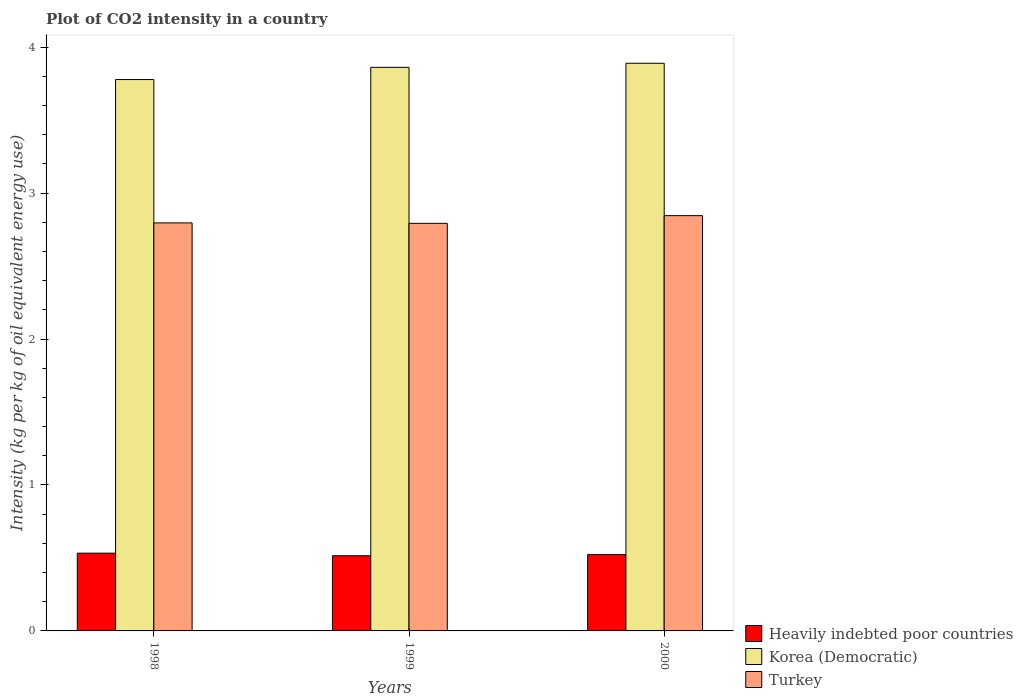How many groups of bars are there?
Offer a very short reply. 3. Are the number of bars per tick equal to the number of legend labels?
Provide a succinct answer. Yes. Are the number of bars on each tick of the X-axis equal?
Provide a succinct answer. Yes. In how many cases, is the number of bars for a given year not equal to the number of legend labels?
Offer a terse response. 0. What is the CO2 intensity in in Korea (Democratic) in 2000?
Your answer should be compact. 3.89. Across all years, what is the maximum CO2 intensity in in Korea (Democratic)?
Make the answer very short. 3.89. Across all years, what is the minimum CO2 intensity in in Korea (Democratic)?
Offer a very short reply. 3.78. In which year was the CO2 intensity in in Turkey maximum?
Your response must be concise. 2000. In which year was the CO2 intensity in in Korea (Democratic) minimum?
Your answer should be very brief. 1998. What is the total CO2 intensity in in Heavily indebted poor countries in the graph?
Provide a succinct answer. 1.57. What is the difference between the CO2 intensity in in Korea (Democratic) in 1999 and that in 2000?
Your answer should be compact. -0.03. What is the difference between the CO2 intensity in in Turkey in 1998 and the CO2 intensity in in Heavily indebted poor countries in 1999?
Ensure brevity in your answer.  2.28. What is the average CO2 intensity in in Korea (Democratic) per year?
Ensure brevity in your answer.  3.84. In the year 1998, what is the difference between the CO2 intensity in in Heavily indebted poor countries and CO2 intensity in in Turkey?
Your answer should be very brief. -2.26. What is the ratio of the CO2 intensity in in Turkey in 1998 to that in 1999?
Offer a terse response. 1. What is the difference between the highest and the second highest CO2 intensity in in Heavily indebted poor countries?
Provide a succinct answer. 0.01. What is the difference between the highest and the lowest CO2 intensity in in Korea (Democratic)?
Your answer should be very brief. 0.11. In how many years, is the CO2 intensity in in Turkey greater than the average CO2 intensity in in Turkey taken over all years?
Ensure brevity in your answer.  1. What does the 2nd bar from the left in 1998 represents?
Your answer should be very brief. Korea (Democratic). What does the 3rd bar from the right in 2000 represents?
Give a very brief answer. Heavily indebted poor countries. How many bars are there?
Give a very brief answer. 9. Are all the bars in the graph horizontal?
Keep it short and to the point. No. How many years are there in the graph?
Give a very brief answer. 3. Are the values on the major ticks of Y-axis written in scientific E-notation?
Give a very brief answer. No. Does the graph contain any zero values?
Make the answer very short. No. Does the graph contain grids?
Offer a very short reply. No. Where does the legend appear in the graph?
Make the answer very short. Bottom right. How many legend labels are there?
Give a very brief answer. 3. How are the legend labels stacked?
Your answer should be very brief. Vertical. What is the title of the graph?
Your answer should be very brief. Plot of CO2 intensity in a country. Does "Chad" appear as one of the legend labels in the graph?
Your answer should be very brief. No. What is the label or title of the X-axis?
Offer a very short reply. Years. What is the label or title of the Y-axis?
Provide a short and direct response. Intensity (kg per kg of oil equivalent energy use). What is the Intensity (kg per kg of oil equivalent energy use) in Heavily indebted poor countries in 1998?
Your answer should be very brief. 0.53. What is the Intensity (kg per kg of oil equivalent energy use) in Korea (Democratic) in 1998?
Ensure brevity in your answer.  3.78. What is the Intensity (kg per kg of oil equivalent energy use) of Turkey in 1998?
Provide a short and direct response. 2.8. What is the Intensity (kg per kg of oil equivalent energy use) of Heavily indebted poor countries in 1999?
Offer a terse response. 0.52. What is the Intensity (kg per kg of oil equivalent energy use) in Korea (Democratic) in 1999?
Keep it short and to the point. 3.86. What is the Intensity (kg per kg of oil equivalent energy use) of Turkey in 1999?
Offer a terse response. 2.79. What is the Intensity (kg per kg of oil equivalent energy use) in Heavily indebted poor countries in 2000?
Offer a very short reply. 0.52. What is the Intensity (kg per kg of oil equivalent energy use) of Korea (Democratic) in 2000?
Your answer should be compact. 3.89. What is the Intensity (kg per kg of oil equivalent energy use) in Turkey in 2000?
Provide a succinct answer. 2.85. Across all years, what is the maximum Intensity (kg per kg of oil equivalent energy use) of Heavily indebted poor countries?
Your response must be concise. 0.53. Across all years, what is the maximum Intensity (kg per kg of oil equivalent energy use) of Korea (Democratic)?
Keep it short and to the point. 3.89. Across all years, what is the maximum Intensity (kg per kg of oil equivalent energy use) in Turkey?
Provide a short and direct response. 2.85. Across all years, what is the minimum Intensity (kg per kg of oil equivalent energy use) of Heavily indebted poor countries?
Offer a terse response. 0.52. Across all years, what is the minimum Intensity (kg per kg of oil equivalent energy use) in Korea (Democratic)?
Provide a short and direct response. 3.78. Across all years, what is the minimum Intensity (kg per kg of oil equivalent energy use) in Turkey?
Provide a short and direct response. 2.79. What is the total Intensity (kg per kg of oil equivalent energy use) in Heavily indebted poor countries in the graph?
Your response must be concise. 1.57. What is the total Intensity (kg per kg of oil equivalent energy use) in Korea (Democratic) in the graph?
Provide a succinct answer. 11.53. What is the total Intensity (kg per kg of oil equivalent energy use) of Turkey in the graph?
Keep it short and to the point. 8.43. What is the difference between the Intensity (kg per kg of oil equivalent energy use) of Heavily indebted poor countries in 1998 and that in 1999?
Your response must be concise. 0.02. What is the difference between the Intensity (kg per kg of oil equivalent energy use) in Korea (Democratic) in 1998 and that in 1999?
Provide a short and direct response. -0.08. What is the difference between the Intensity (kg per kg of oil equivalent energy use) of Turkey in 1998 and that in 1999?
Offer a terse response. 0. What is the difference between the Intensity (kg per kg of oil equivalent energy use) in Heavily indebted poor countries in 1998 and that in 2000?
Make the answer very short. 0.01. What is the difference between the Intensity (kg per kg of oil equivalent energy use) in Korea (Democratic) in 1998 and that in 2000?
Your answer should be compact. -0.11. What is the difference between the Intensity (kg per kg of oil equivalent energy use) in Turkey in 1998 and that in 2000?
Provide a short and direct response. -0.05. What is the difference between the Intensity (kg per kg of oil equivalent energy use) in Heavily indebted poor countries in 1999 and that in 2000?
Give a very brief answer. -0.01. What is the difference between the Intensity (kg per kg of oil equivalent energy use) in Korea (Democratic) in 1999 and that in 2000?
Your response must be concise. -0.03. What is the difference between the Intensity (kg per kg of oil equivalent energy use) of Turkey in 1999 and that in 2000?
Give a very brief answer. -0.05. What is the difference between the Intensity (kg per kg of oil equivalent energy use) of Heavily indebted poor countries in 1998 and the Intensity (kg per kg of oil equivalent energy use) of Korea (Democratic) in 1999?
Provide a succinct answer. -3.33. What is the difference between the Intensity (kg per kg of oil equivalent energy use) of Heavily indebted poor countries in 1998 and the Intensity (kg per kg of oil equivalent energy use) of Turkey in 1999?
Give a very brief answer. -2.26. What is the difference between the Intensity (kg per kg of oil equivalent energy use) in Korea (Democratic) in 1998 and the Intensity (kg per kg of oil equivalent energy use) in Turkey in 1999?
Provide a succinct answer. 0.99. What is the difference between the Intensity (kg per kg of oil equivalent energy use) in Heavily indebted poor countries in 1998 and the Intensity (kg per kg of oil equivalent energy use) in Korea (Democratic) in 2000?
Offer a very short reply. -3.36. What is the difference between the Intensity (kg per kg of oil equivalent energy use) of Heavily indebted poor countries in 1998 and the Intensity (kg per kg of oil equivalent energy use) of Turkey in 2000?
Make the answer very short. -2.31. What is the difference between the Intensity (kg per kg of oil equivalent energy use) in Korea (Democratic) in 1998 and the Intensity (kg per kg of oil equivalent energy use) in Turkey in 2000?
Your answer should be very brief. 0.93. What is the difference between the Intensity (kg per kg of oil equivalent energy use) of Heavily indebted poor countries in 1999 and the Intensity (kg per kg of oil equivalent energy use) of Korea (Democratic) in 2000?
Give a very brief answer. -3.38. What is the difference between the Intensity (kg per kg of oil equivalent energy use) in Heavily indebted poor countries in 1999 and the Intensity (kg per kg of oil equivalent energy use) in Turkey in 2000?
Provide a short and direct response. -2.33. What is the difference between the Intensity (kg per kg of oil equivalent energy use) of Korea (Democratic) in 1999 and the Intensity (kg per kg of oil equivalent energy use) of Turkey in 2000?
Keep it short and to the point. 1.02. What is the average Intensity (kg per kg of oil equivalent energy use) in Heavily indebted poor countries per year?
Keep it short and to the point. 0.52. What is the average Intensity (kg per kg of oil equivalent energy use) in Korea (Democratic) per year?
Ensure brevity in your answer.  3.84. What is the average Intensity (kg per kg of oil equivalent energy use) of Turkey per year?
Ensure brevity in your answer.  2.81. In the year 1998, what is the difference between the Intensity (kg per kg of oil equivalent energy use) of Heavily indebted poor countries and Intensity (kg per kg of oil equivalent energy use) of Korea (Democratic)?
Give a very brief answer. -3.25. In the year 1998, what is the difference between the Intensity (kg per kg of oil equivalent energy use) in Heavily indebted poor countries and Intensity (kg per kg of oil equivalent energy use) in Turkey?
Your response must be concise. -2.26. In the year 1998, what is the difference between the Intensity (kg per kg of oil equivalent energy use) of Korea (Democratic) and Intensity (kg per kg of oil equivalent energy use) of Turkey?
Your response must be concise. 0.98. In the year 1999, what is the difference between the Intensity (kg per kg of oil equivalent energy use) of Heavily indebted poor countries and Intensity (kg per kg of oil equivalent energy use) of Korea (Democratic)?
Provide a succinct answer. -3.35. In the year 1999, what is the difference between the Intensity (kg per kg of oil equivalent energy use) of Heavily indebted poor countries and Intensity (kg per kg of oil equivalent energy use) of Turkey?
Provide a succinct answer. -2.28. In the year 1999, what is the difference between the Intensity (kg per kg of oil equivalent energy use) in Korea (Democratic) and Intensity (kg per kg of oil equivalent energy use) in Turkey?
Provide a succinct answer. 1.07. In the year 2000, what is the difference between the Intensity (kg per kg of oil equivalent energy use) in Heavily indebted poor countries and Intensity (kg per kg of oil equivalent energy use) in Korea (Democratic)?
Offer a very short reply. -3.37. In the year 2000, what is the difference between the Intensity (kg per kg of oil equivalent energy use) of Heavily indebted poor countries and Intensity (kg per kg of oil equivalent energy use) of Turkey?
Your response must be concise. -2.32. In the year 2000, what is the difference between the Intensity (kg per kg of oil equivalent energy use) of Korea (Democratic) and Intensity (kg per kg of oil equivalent energy use) of Turkey?
Give a very brief answer. 1.04. What is the ratio of the Intensity (kg per kg of oil equivalent energy use) in Heavily indebted poor countries in 1998 to that in 1999?
Provide a short and direct response. 1.03. What is the ratio of the Intensity (kg per kg of oil equivalent energy use) in Korea (Democratic) in 1998 to that in 1999?
Make the answer very short. 0.98. What is the ratio of the Intensity (kg per kg of oil equivalent energy use) in Turkey in 1998 to that in 1999?
Offer a terse response. 1. What is the ratio of the Intensity (kg per kg of oil equivalent energy use) of Heavily indebted poor countries in 1998 to that in 2000?
Offer a terse response. 1.02. What is the ratio of the Intensity (kg per kg of oil equivalent energy use) in Korea (Democratic) in 1998 to that in 2000?
Keep it short and to the point. 0.97. What is the ratio of the Intensity (kg per kg of oil equivalent energy use) in Turkey in 1998 to that in 2000?
Provide a succinct answer. 0.98. What is the ratio of the Intensity (kg per kg of oil equivalent energy use) in Heavily indebted poor countries in 1999 to that in 2000?
Give a very brief answer. 0.98. What is the ratio of the Intensity (kg per kg of oil equivalent energy use) in Korea (Democratic) in 1999 to that in 2000?
Your response must be concise. 0.99. What is the ratio of the Intensity (kg per kg of oil equivalent energy use) of Turkey in 1999 to that in 2000?
Provide a succinct answer. 0.98. What is the difference between the highest and the second highest Intensity (kg per kg of oil equivalent energy use) in Heavily indebted poor countries?
Your answer should be very brief. 0.01. What is the difference between the highest and the second highest Intensity (kg per kg of oil equivalent energy use) of Korea (Democratic)?
Offer a terse response. 0.03. What is the difference between the highest and the second highest Intensity (kg per kg of oil equivalent energy use) of Turkey?
Keep it short and to the point. 0.05. What is the difference between the highest and the lowest Intensity (kg per kg of oil equivalent energy use) in Heavily indebted poor countries?
Offer a very short reply. 0.02. What is the difference between the highest and the lowest Intensity (kg per kg of oil equivalent energy use) of Korea (Democratic)?
Provide a short and direct response. 0.11. What is the difference between the highest and the lowest Intensity (kg per kg of oil equivalent energy use) of Turkey?
Provide a succinct answer. 0.05. 